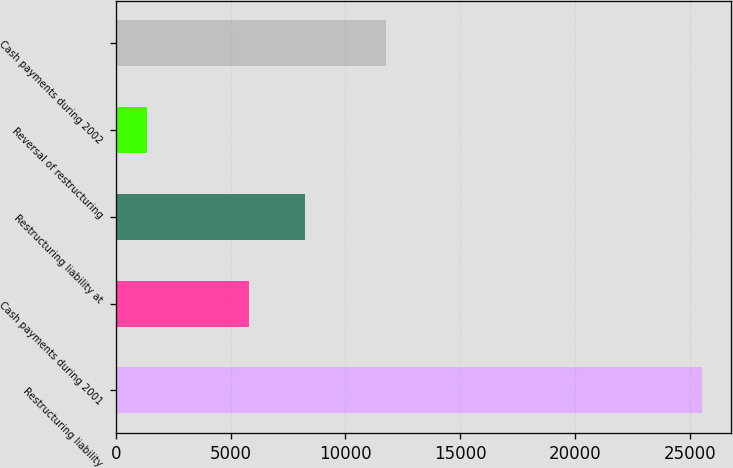<chart> <loc_0><loc_0><loc_500><loc_500><bar_chart><fcel>Restructuring liability<fcel>Cash payments during 2001<fcel>Restructuring liability at<fcel>Reversal of restructuring<fcel>Cash payments during 2002<nl><fcel>25518<fcel>5821<fcel>8238<fcel>1348<fcel>11779<nl></chart> 